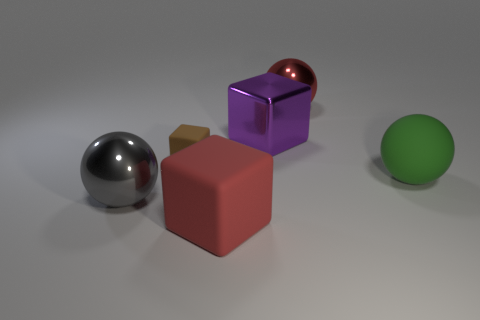There is a red object in front of the red metal sphere; is its size the same as the big purple object?
Ensure brevity in your answer.  Yes. Is the small matte block the same color as the shiny block?
Make the answer very short. No. What number of big things are both in front of the purple cube and to the right of the metal cube?
Offer a very short reply. 1. How many purple objects are on the left side of the shiny ball right of the sphere that is to the left of the tiny matte object?
Your answer should be very brief. 1. There is a object that is the same color as the big rubber cube; what size is it?
Provide a succinct answer. Large. What shape is the large red metal thing?
Your response must be concise. Sphere. What number of other large green spheres are made of the same material as the big green ball?
Provide a succinct answer. 0. What color is the large sphere that is the same material as the large red block?
Give a very brief answer. Green. There is a purple shiny object; is it the same size as the sphere to the left of the red metal sphere?
Your response must be concise. Yes. There is a cube that is in front of the big gray sphere on the left side of the red rubber object that is in front of the big green rubber sphere; what is it made of?
Your response must be concise. Rubber. 